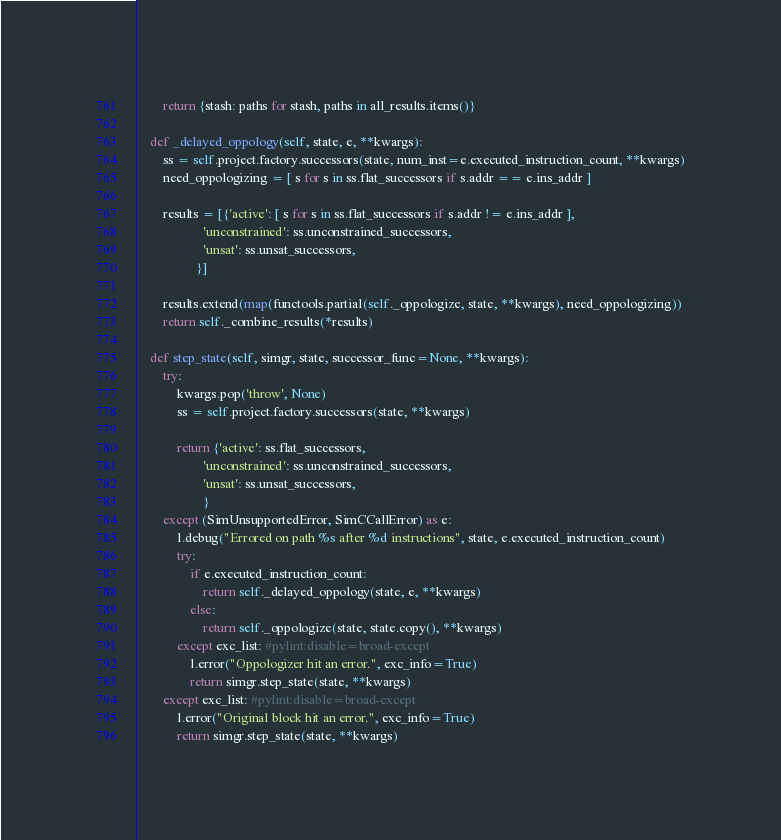<code> <loc_0><loc_0><loc_500><loc_500><_Python_>
        return {stash: paths for stash, paths in all_results.items()}

    def _delayed_oppology(self, state, e, **kwargs):
        ss = self.project.factory.successors(state, num_inst=e.executed_instruction_count, **kwargs)
        need_oppologizing = [ s for s in ss.flat_successors if s.addr == e.ins_addr ]

        results = [{'active': [ s for s in ss.flat_successors if s.addr != e.ins_addr ],
                    'unconstrained': ss.unconstrained_successors,
                    'unsat': ss.unsat_successors,
                  }]

        results.extend(map(functools.partial(self._oppologize, state, **kwargs), need_oppologizing))
        return self._combine_results(*results)

    def step_state(self, simgr, state, successor_func=None, **kwargs):
        try:
            kwargs.pop('throw', None)
            ss = self.project.factory.successors(state, **kwargs)

            return {'active': ss.flat_successors,
                    'unconstrained': ss.unconstrained_successors,
                    'unsat': ss.unsat_successors,
                    }
        except (SimUnsupportedError, SimCCallError) as e:
            l.debug("Errored on path %s after %d instructions", state, e.executed_instruction_count)
            try:
                if e.executed_instruction_count:
                    return self._delayed_oppology(state, e, **kwargs)
                else:
                    return self._oppologize(state, state.copy(), **kwargs)
            except exc_list: #pylint:disable=broad-except
                l.error("Oppologizer hit an error.", exc_info=True)
                return simgr.step_state(state, **kwargs)
        except exc_list: #pylint:disable=broad-except
            l.error("Original block hit an error.", exc_info=True)
            return simgr.step_state(state, **kwargs)
</code> 